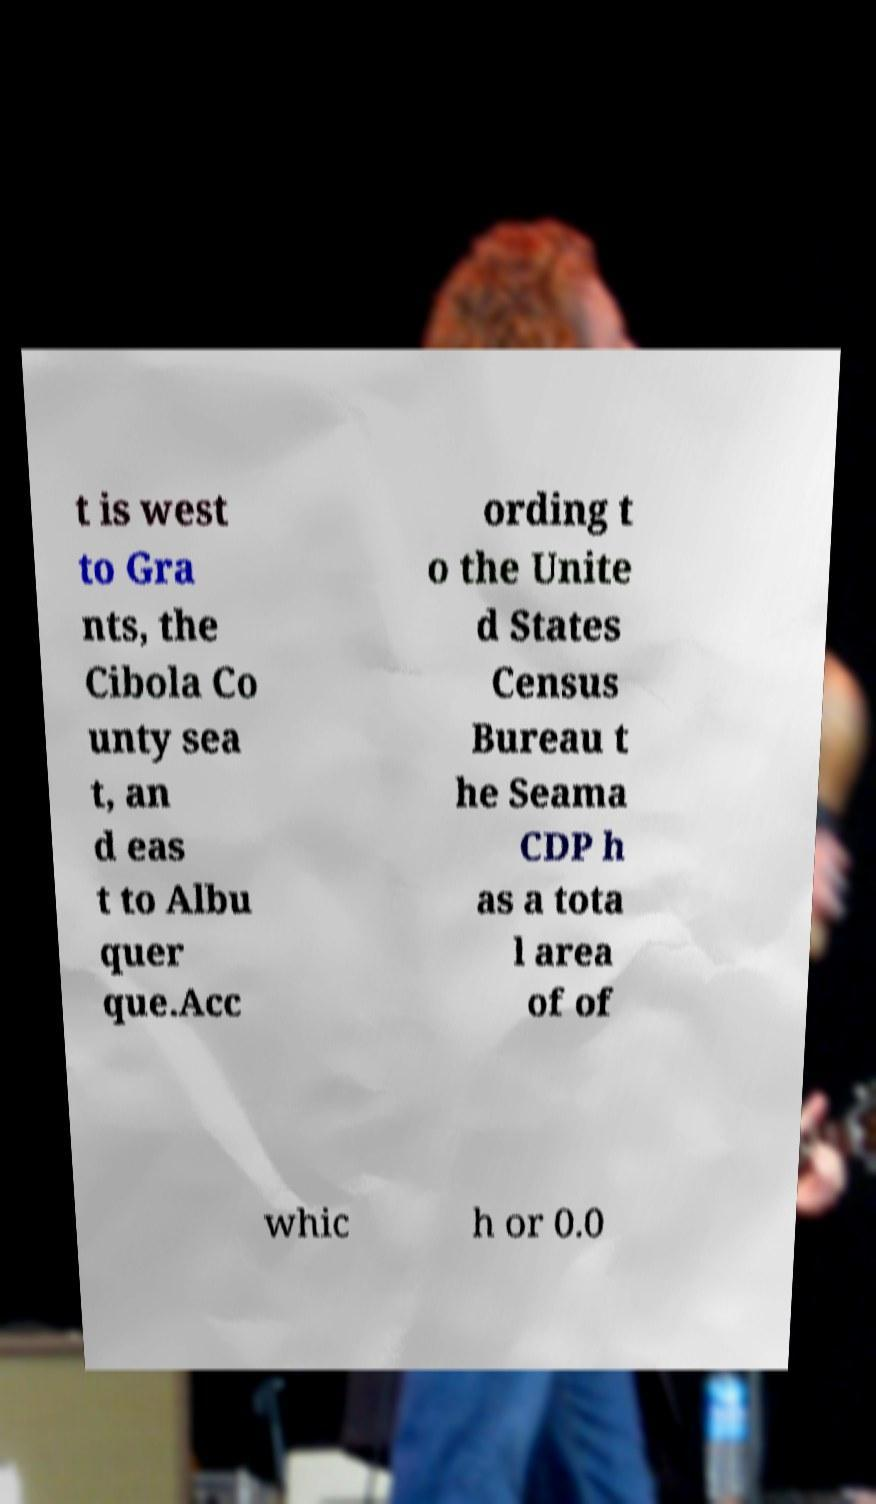There's text embedded in this image that I need extracted. Can you transcribe it verbatim? t is west to Gra nts, the Cibola Co unty sea t, an d eas t to Albu quer que.Acc ording t o the Unite d States Census Bureau t he Seama CDP h as a tota l area of of whic h or 0.0 